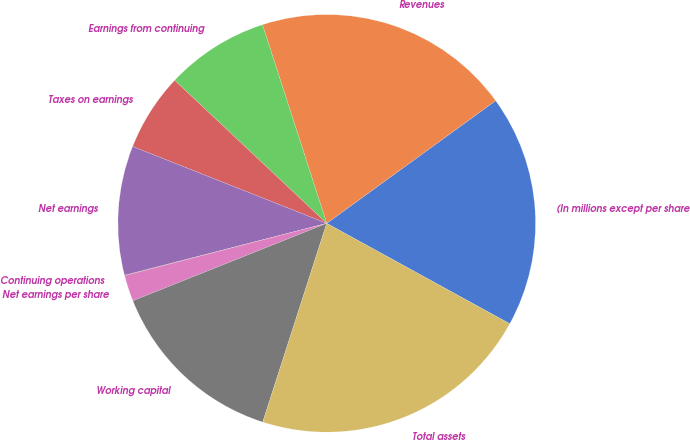Convert chart to OTSL. <chart><loc_0><loc_0><loc_500><loc_500><pie_chart><fcel>(In millions except per share<fcel>Revenues<fcel>Earnings from continuing<fcel>Taxes on earnings<fcel>Net earnings<fcel>Continuing operations<fcel>Net earnings per share<fcel>Working capital<fcel>Total assets<nl><fcel>17.98%<fcel>19.98%<fcel>8.01%<fcel>6.01%<fcel>10.0%<fcel>0.03%<fcel>2.02%<fcel>13.99%<fcel>21.97%<nl></chart> 